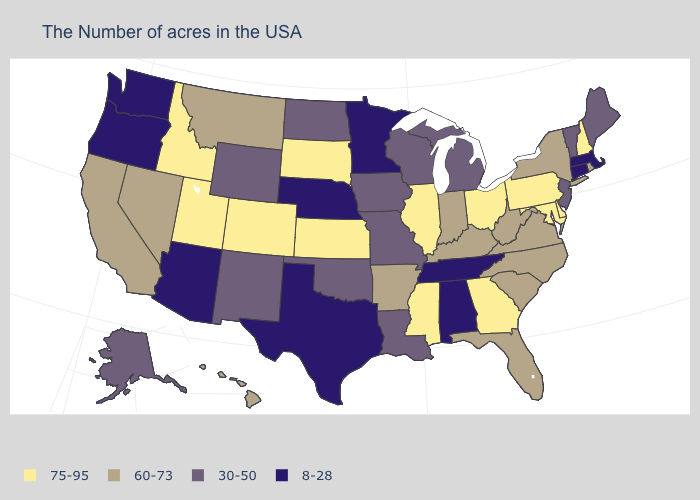Name the states that have a value in the range 8-28?
Quick response, please. Massachusetts, Connecticut, Alabama, Tennessee, Minnesota, Nebraska, Texas, Arizona, Washington, Oregon. Does the first symbol in the legend represent the smallest category?
Keep it brief. No. How many symbols are there in the legend?
Write a very short answer. 4. What is the lowest value in the MidWest?
Quick response, please. 8-28. Does the first symbol in the legend represent the smallest category?
Quick response, please. No. Name the states that have a value in the range 60-73?
Give a very brief answer. Rhode Island, New York, Virginia, North Carolina, South Carolina, West Virginia, Florida, Kentucky, Indiana, Arkansas, Montana, Nevada, California, Hawaii. Which states have the lowest value in the MidWest?
Keep it brief. Minnesota, Nebraska. Does the first symbol in the legend represent the smallest category?
Keep it brief. No. Which states hav the highest value in the MidWest?
Concise answer only. Ohio, Illinois, Kansas, South Dakota. Does the first symbol in the legend represent the smallest category?
Write a very short answer. No. Does Pennsylvania have the highest value in the Northeast?
Concise answer only. Yes. Name the states that have a value in the range 75-95?
Give a very brief answer. New Hampshire, Delaware, Maryland, Pennsylvania, Ohio, Georgia, Illinois, Mississippi, Kansas, South Dakota, Colorado, Utah, Idaho. Does South Dakota have the highest value in the USA?
Write a very short answer. Yes. Which states have the lowest value in the USA?
Give a very brief answer. Massachusetts, Connecticut, Alabama, Tennessee, Minnesota, Nebraska, Texas, Arizona, Washington, Oregon. How many symbols are there in the legend?
Give a very brief answer. 4. 